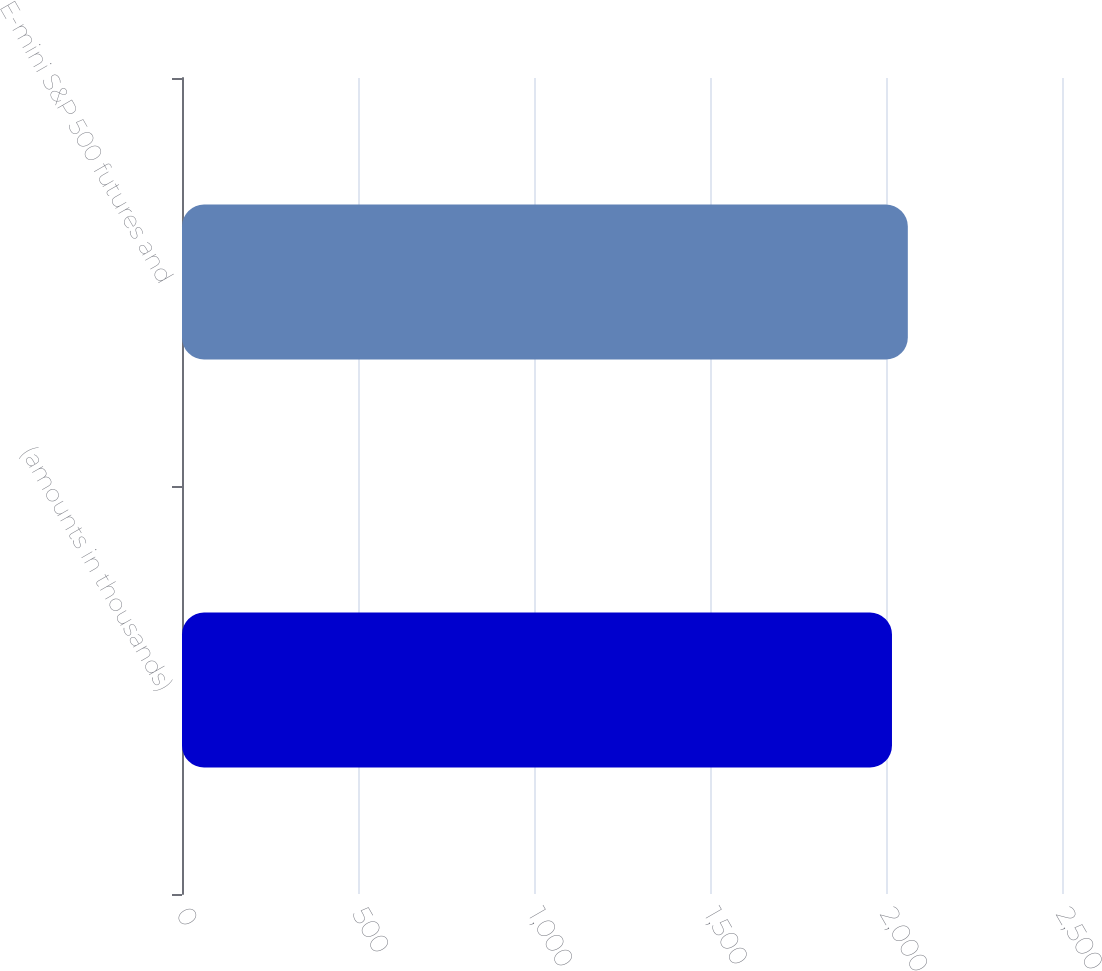Convert chart to OTSL. <chart><loc_0><loc_0><loc_500><loc_500><bar_chart><fcel>(amounts in thousands)<fcel>E-mini S&P 500 futures and<nl><fcel>2017<fcel>2062<nl></chart> 